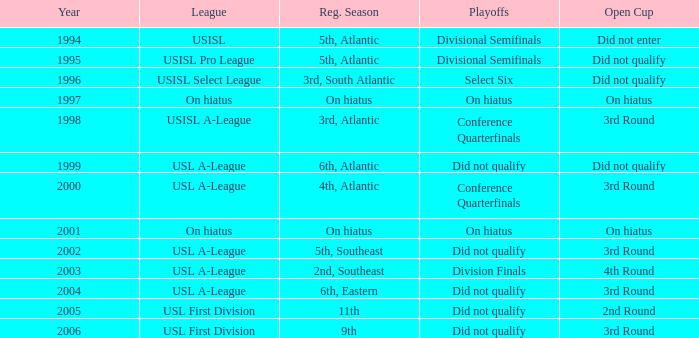When was the inaugural year of the usisl pro league? 1995.0. 